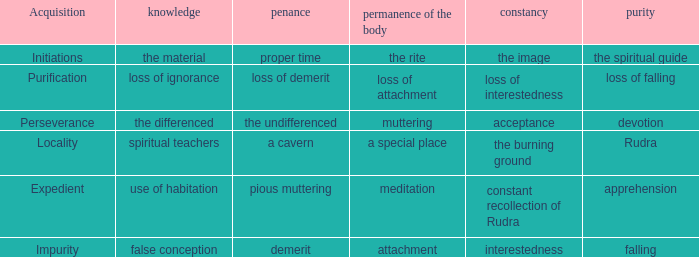Can you parse all the data within this table? {'header': ['Acquisition', 'knowledge', 'penance', 'permanence of the body', 'constancy', 'purity'], 'rows': [['Initiations', 'the material', 'proper time', 'the rite', 'the image', 'the spiritual guide'], ['Purification', 'loss of ignorance', 'loss of demerit', 'loss of attachment', 'loss of interestedness', 'loss of falling'], ['Perseverance', 'the differenced', 'the undifferenced', 'muttering', 'acceptance', 'devotion'], ['Locality', 'spiritual teachers', 'a cavern', 'a special place', 'the burning ground', 'Rudra'], ['Expedient', 'use of habitation', 'pious muttering', 'meditation', 'constant recollection of Rudra', 'apprehension'], ['Impurity', 'false conception', 'demerit', 'attachment', 'interestedness', 'falling']]}  what's the permanence of the body where purity is apprehension Meditation. 